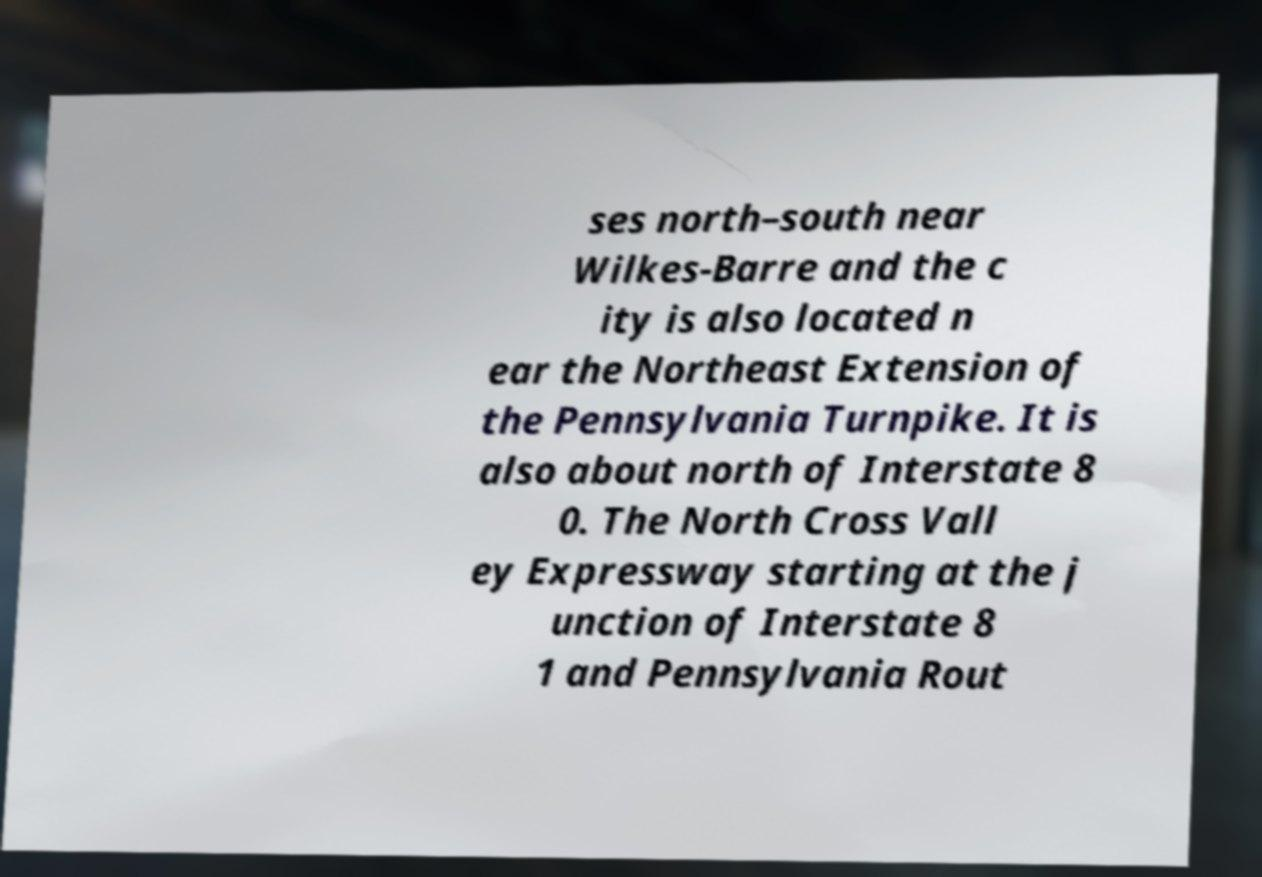There's text embedded in this image that I need extracted. Can you transcribe it verbatim? ses north–south near Wilkes-Barre and the c ity is also located n ear the Northeast Extension of the Pennsylvania Turnpike. It is also about north of Interstate 8 0. The North Cross Vall ey Expressway starting at the j unction of Interstate 8 1 and Pennsylvania Rout 